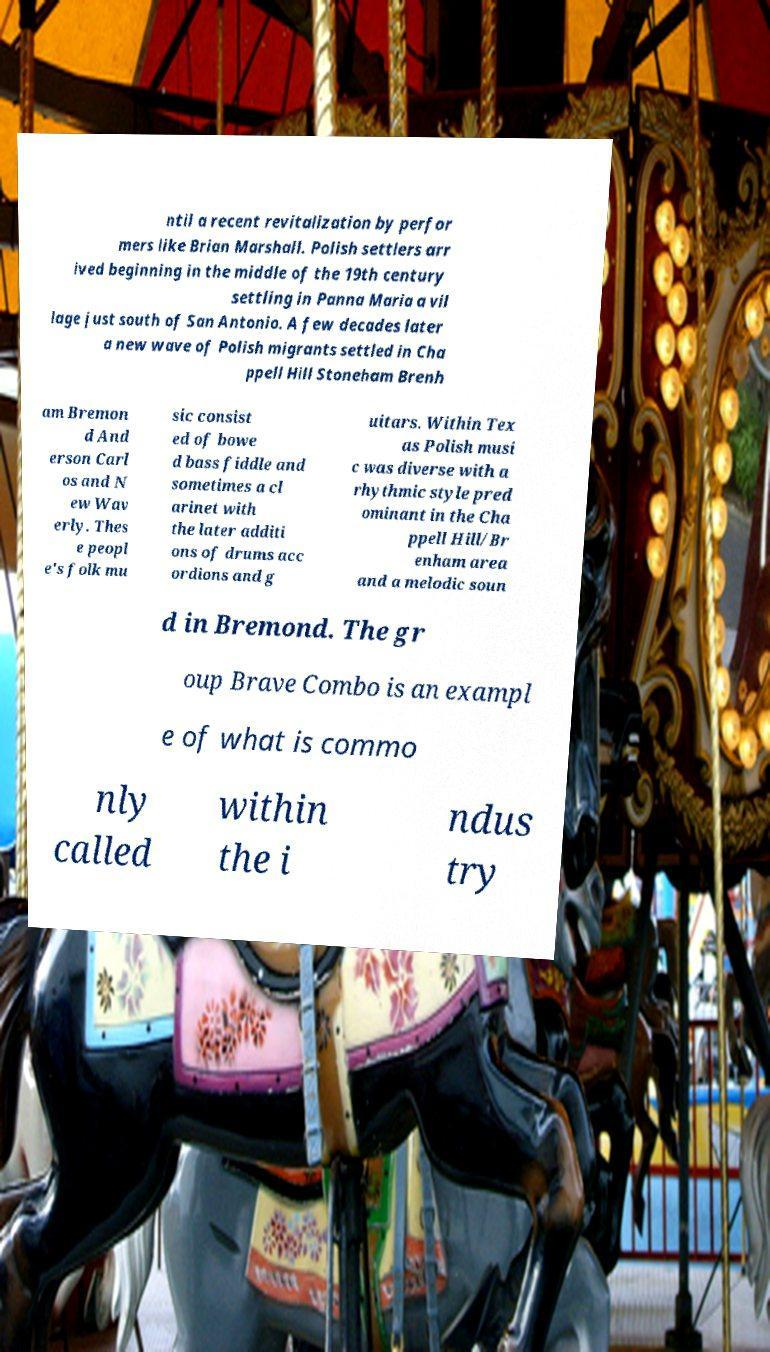Could you assist in decoding the text presented in this image and type it out clearly? ntil a recent revitalization by perfor mers like Brian Marshall. Polish settlers arr ived beginning in the middle of the 19th century settling in Panna Maria a vil lage just south of San Antonio. A few decades later a new wave of Polish migrants settled in Cha ppell Hill Stoneham Brenh am Bremon d And erson Carl os and N ew Wav erly. Thes e peopl e's folk mu sic consist ed of bowe d bass fiddle and sometimes a cl arinet with the later additi ons of drums acc ordions and g uitars. Within Tex as Polish musi c was diverse with a rhythmic style pred ominant in the Cha ppell Hill/Br enham area and a melodic soun d in Bremond. The gr oup Brave Combo is an exampl e of what is commo nly called within the i ndus try 